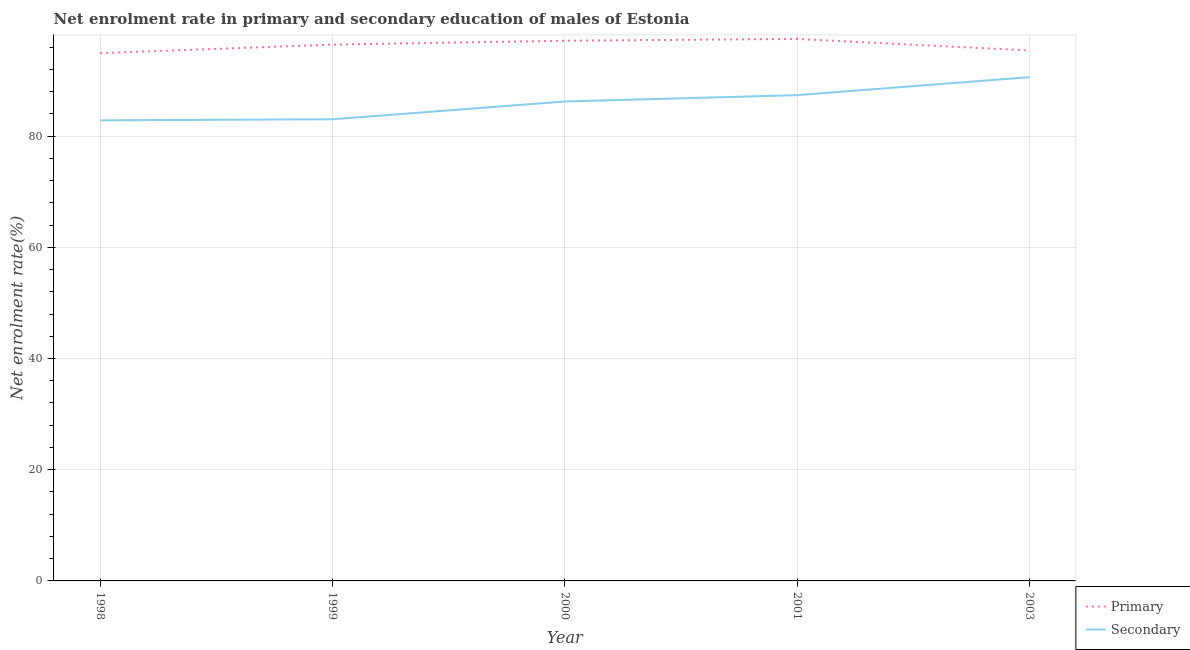Is the number of lines equal to the number of legend labels?
Give a very brief answer. Yes. What is the enrollment rate in secondary education in 2000?
Your answer should be very brief. 86.23. Across all years, what is the maximum enrollment rate in secondary education?
Your response must be concise. 90.6. Across all years, what is the minimum enrollment rate in primary education?
Provide a succinct answer. 94.92. In which year was the enrollment rate in secondary education maximum?
Your response must be concise. 2003. What is the total enrollment rate in secondary education in the graph?
Keep it short and to the point. 430.06. What is the difference between the enrollment rate in primary education in 1999 and that in 2000?
Provide a short and direct response. -0.7. What is the difference between the enrollment rate in secondary education in 2003 and the enrollment rate in primary education in 2001?
Offer a very short reply. -6.87. What is the average enrollment rate in secondary education per year?
Make the answer very short. 86.01. In the year 2000, what is the difference between the enrollment rate in primary education and enrollment rate in secondary education?
Give a very brief answer. 10.93. What is the ratio of the enrollment rate in secondary education in 1998 to that in 2000?
Offer a very short reply. 0.96. What is the difference between the highest and the second highest enrollment rate in secondary education?
Your answer should be compact. 3.23. What is the difference between the highest and the lowest enrollment rate in primary education?
Your response must be concise. 2.56. In how many years, is the enrollment rate in secondary education greater than the average enrollment rate in secondary education taken over all years?
Keep it short and to the point. 3. Is the sum of the enrollment rate in secondary education in 1999 and 2000 greater than the maximum enrollment rate in primary education across all years?
Your answer should be very brief. Yes. Does the enrollment rate in secondary education monotonically increase over the years?
Your answer should be compact. Yes. Is the enrollment rate in secondary education strictly greater than the enrollment rate in primary education over the years?
Make the answer very short. No. Is the enrollment rate in secondary education strictly less than the enrollment rate in primary education over the years?
Your answer should be very brief. Yes. How many years are there in the graph?
Your answer should be compact. 5. Are the values on the major ticks of Y-axis written in scientific E-notation?
Your answer should be very brief. No. Where does the legend appear in the graph?
Ensure brevity in your answer.  Bottom right. What is the title of the graph?
Your response must be concise. Net enrolment rate in primary and secondary education of males of Estonia. What is the label or title of the X-axis?
Your answer should be very brief. Year. What is the label or title of the Y-axis?
Your answer should be compact. Net enrolment rate(%). What is the Net enrolment rate(%) in Primary in 1998?
Ensure brevity in your answer.  94.92. What is the Net enrolment rate(%) of Secondary in 1998?
Provide a succinct answer. 82.83. What is the Net enrolment rate(%) in Primary in 1999?
Your answer should be compact. 96.46. What is the Net enrolment rate(%) in Secondary in 1999?
Provide a succinct answer. 83.03. What is the Net enrolment rate(%) of Primary in 2000?
Ensure brevity in your answer.  97.16. What is the Net enrolment rate(%) in Secondary in 2000?
Give a very brief answer. 86.23. What is the Net enrolment rate(%) of Primary in 2001?
Provide a short and direct response. 97.47. What is the Net enrolment rate(%) in Secondary in 2001?
Offer a very short reply. 87.37. What is the Net enrolment rate(%) in Primary in 2003?
Keep it short and to the point. 95.4. What is the Net enrolment rate(%) in Secondary in 2003?
Give a very brief answer. 90.6. Across all years, what is the maximum Net enrolment rate(%) of Primary?
Provide a short and direct response. 97.47. Across all years, what is the maximum Net enrolment rate(%) in Secondary?
Offer a very short reply. 90.6. Across all years, what is the minimum Net enrolment rate(%) of Primary?
Keep it short and to the point. 94.92. Across all years, what is the minimum Net enrolment rate(%) in Secondary?
Provide a short and direct response. 82.83. What is the total Net enrolment rate(%) of Primary in the graph?
Make the answer very short. 481.4. What is the total Net enrolment rate(%) in Secondary in the graph?
Your answer should be very brief. 430.06. What is the difference between the Net enrolment rate(%) in Primary in 1998 and that in 1999?
Your response must be concise. -1.54. What is the difference between the Net enrolment rate(%) in Secondary in 1998 and that in 1999?
Offer a terse response. -0.2. What is the difference between the Net enrolment rate(%) in Primary in 1998 and that in 2000?
Ensure brevity in your answer.  -2.24. What is the difference between the Net enrolment rate(%) in Secondary in 1998 and that in 2000?
Provide a short and direct response. -3.39. What is the difference between the Net enrolment rate(%) in Primary in 1998 and that in 2001?
Your answer should be very brief. -2.56. What is the difference between the Net enrolment rate(%) of Secondary in 1998 and that in 2001?
Give a very brief answer. -4.54. What is the difference between the Net enrolment rate(%) of Primary in 1998 and that in 2003?
Provide a short and direct response. -0.48. What is the difference between the Net enrolment rate(%) in Secondary in 1998 and that in 2003?
Your response must be concise. -7.77. What is the difference between the Net enrolment rate(%) in Primary in 1999 and that in 2000?
Offer a terse response. -0.7. What is the difference between the Net enrolment rate(%) of Secondary in 1999 and that in 2000?
Provide a short and direct response. -3.2. What is the difference between the Net enrolment rate(%) of Primary in 1999 and that in 2001?
Your answer should be compact. -1.02. What is the difference between the Net enrolment rate(%) in Secondary in 1999 and that in 2001?
Keep it short and to the point. -4.34. What is the difference between the Net enrolment rate(%) of Primary in 1999 and that in 2003?
Your answer should be very brief. 1.06. What is the difference between the Net enrolment rate(%) in Secondary in 1999 and that in 2003?
Keep it short and to the point. -7.57. What is the difference between the Net enrolment rate(%) of Primary in 2000 and that in 2001?
Keep it short and to the point. -0.32. What is the difference between the Net enrolment rate(%) of Secondary in 2000 and that in 2001?
Make the answer very short. -1.14. What is the difference between the Net enrolment rate(%) in Primary in 2000 and that in 2003?
Offer a very short reply. 1.76. What is the difference between the Net enrolment rate(%) of Secondary in 2000 and that in 2003?
Your answer should be compact. -4.38. What is the difference between the Net enrolment rate(%) of Primary in 2001 and that in 2003?
Your answer should be compact. 2.08. What is the difference between the Net enrolment rate(%) in Secondary in 2001 and that in 2003?
Offer a very short reply. -3.23. What is the difference between the Net enrolment rate(%) of Primary in 1998 and the Net enrolment rate(%) of Secondary in 1999?
Make the answer very short. 11.89. What is the difference between the Net enrolment rate(%) of Primary in 1998 and the Net enrolment rate(%) of Secondary in 2000?
Provide a short and direct response. 8.69. What is the difference between the Net enrolment rate(%) in Primary in 1998 and the Net enrolment rate(%) in Secondary in 2001?
Provide a succinct answer. 7.55. What is the difference between the Net enrolment rate(%) in Primary in 1998 and the Net enrolment rate(%) in Secondary in 2003?
Your answer should be very brief. 4.31. What is the difference between the Net enrolment rate(%) in Primary in 1999 and the Net enrolment rate(%) in Secondary in 2000?
Your answer should be very brief. 10.23. What is the difference between the Net enrolment rate(%) of Primary in 1999 and the Net enrolment rate(%) of Secondary in 2001?
Your answer should be very brief. 9.09. What is the difference between the Net enrolment rate(%) in Primary in 1999 and the Net enrolment rate(%) in Secondary in 2003?
Give a very brief answer. 5.86. What is the difference between the Net enrolment rate(%) in Primary in 2000 and the Net enrolment rate(%) in Secondary in 2001?
Keep it short and to the point. 9.79. What is the difference between the Net enrolment rate(%) of Primary in 2000 and the Net enrolment rate(%) of Secondary in 2003?
Offer a terse response. 6.55. What is the difference between the Net enrolment rate(%) in Primary in 2001 and the Net enrolment rate(%) in Secondary in 2003?
Offer a very short reply. 6.87. What is the average Net enrolment rate(%) in Primary per year?
Ensure brevity in your answer.  96.28. What is the average Net enrolment rate(%) in Secondary per year?
Ensure brevity in your answer.  86.01. In the year 1998, what is the difference between the Net enrolment rate(%) in Primary and Net enrolment rate(%) in Secondary?
Ensure brevity in your answer.  12.08. In the year 1999, what is the difference between the Net enrolment rate(%) of Primary and Net enrolment rate(%) of Secondary?
Provide a short and direct response. 13.43. In the year 2000, what is the difference between the Net enrolment rate(%) of Primary and Net enrolment rate(%) of Secondary?
Provide a short and direct response. 10.93. In the year 2001, what is the difference between the Net enrolment rate(%) of Primary and Net enrolment rate(%) of Secondary?
Your answer should be very brief. 10.11. In the year 2003, what is the difference between the Net enrolment rate(%) in Primary and Net enrolment rate(%) in Secondary?
Ensure brevity in your answer.  4.8. What is the ratio of the Net enrolment rate(%) in Primary in 1998 to that in 1999?
Offer a very short reply. 0.98. What is the ratio of the Net enrolment rate(%) in Secondary in 1998 to that in 2000?
Offer a very short reply. 0.96. What is the ratio of the Net enrolment rate(%) of Primary in 1998 to that in 2001?
Provide a short and direct response. 0.97. What is the ratio of the Net enrolment rate(%) of Secondary in 1998 to that in 2001?
Offer a terse response. 0.95. What is the ratio of the Net enrolment rate(%) in Primary in 1998 to that in 2003?
Make the answer very short. 0.99. What is the ratio of the Net enrolment rate(%) of Secondary in 1998 to that in 2003?
Your answer should be compact. 0.91. What is the ratio of the Net enrolment rate(%) of Primary in 1999 to that in 2000?
Your response must be concise. 0.99. What is the ratio of the Net enrolment rate(%) of Secondary in 1999 to that in 2000?
Ensure brevity in your answer.  0.96. What is the ratio of the Net enrolment rate(%) of Primary in 1999 to that in 2001?
Provide a succinct answer. 0.99. What is the ratio of the Net enrolment rate(%) of Secondary in 1999 to that in 2001?
Keep it short and to the point. 0.95. What is the ratio of the Net enrolment rate(%) in Primary in 1999 to that in 2003?
Provide a short and direct response. 1.01. What is the ratio of the Net enrolment rate(%) in Secondary in 1999 to that in 2003?
Make the answer very short. 0.92. What is the ratio of the Net enrolment rate(%) of Secondary in 2000 to that in 2001?
Ensure brevity in your answer.  0.99. What is the ratio of the Net enrolment rate(%) in Primary in 2000 to that in 2003?
Your answer should be compact. 1.02. What is the ratio of the Net enrolment rate(%) of Secondary in 2000 to that in 2003?
Your answer should be compact. 0.95. What is the ratio of the Net enrolment rate(%) in Primary in 2001 to that in 2003?
Offer a terse response. 1.02. What is the difference between the highest and the second highest Net enrolment rate(%) of Primary?
Keep it short and to the point. 0.32. What is the difference between the highest and the second highest Net enrolment rate(%) in Secondary?
Ensure brevity in your answer.  3.23. What is the difference between the highest and the lowest Net enrolment rate(%) of Primary?
Your answer should be compact. 2.56. What is the difference between the highest and the lowest Net enrolment rate(%) of Secondary?
Your answer should be very brief. 7.77. 